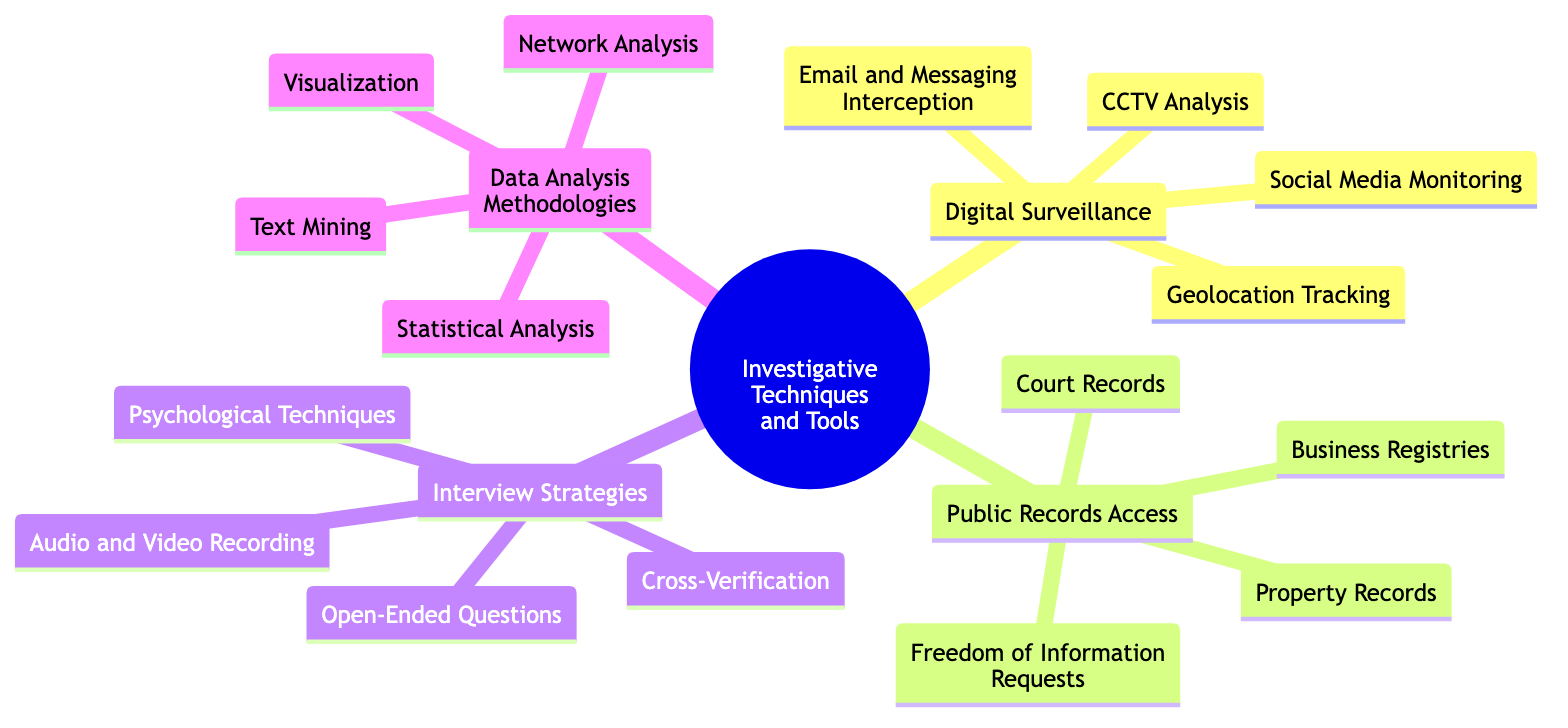What are the four main branches of the mind map? The main branches of the mind map are "Digital Surveillance," "Public Records Access," "Interview Strategies," and "Data Analysis Methodologies."
Answer: Digital Surveillance, Public Records Access, Interview Strategies, Data Analysis Methodologies How many sub-elements does "Digital Surveillance" have? "Digital Surveillance" has four sub-elements: CCTV Analysis, Social Media Monitoring, Geolocation Tracking, and Email and Messaging Interception.
Answer: 4 What technique is associated with the use of GPS data? The technique associated with the use of GPS data is "Geolocation Tracking."
Answer: Geolocation Tracking Which investigative tool comes under "Interview Strategies" and involves documenting conversations? The investigative tool that involves documenting conversations is "Audio and Video Recording."
Answer: Audio and Video Recording What type of analytical method uses natural language processing tools? The analytical method that uses natural language processing tools is "Text Mining."
Answer: Text Mining What is the purpose of "Freedom of Information Requests"? The purpose of "Freedom of Information Requests" is to submit requests to obtain government data.
Answer: Submit FOIA requests to obtain government data Which category does "Network Analysis" belong to? "Network Analysis" belongs to the category of "Data Analysis Methodologies."
Answer: Data Analysis Methodologies How many sub-elements are there under "Public Records Access"? There are four sub-elements under "Public Records Access": Freedom of Information Requests, Court Records, Property Records, and Business Registries.
Answer: 4 What is the relationship between "Statistical Analysis" and a software tool? "Statistical Analysis" is associated with software like SPSS or R for quantitative analysis.
Answer: SPSS or R What questioning technique helps to elicit detailed responses? The questioning technique that helps elicit detailed responses is "Open-Ended Questions."
Answer: Open-Ended Questions 